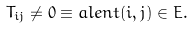Convert formula to latex. <formula><loc_0><loc_0><loc_500><loc_500>T _ { i j } \neq 0 \equiv a l e n t ( i , j ) \in E .</formula> 